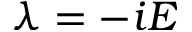Convert formula to latex. <formula><loc_0><loc_0><loc_500><loc_500>\lambda = - i E</formula> 